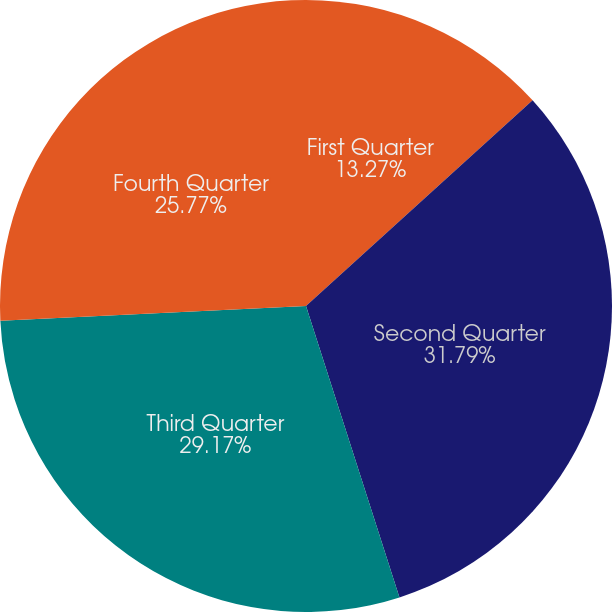Convert chart. <chart><loc_0><loc_0><loc_500><loc_500><pie_chart><fcel>First Quarter<fcel>Second Quarter<fcel>Third Quarter<fcel>Fourth Quarter<nl><fcel>13.27%<fcel>31.79%<fcel>29.17%<fcel>25.77%<nl></chart> 